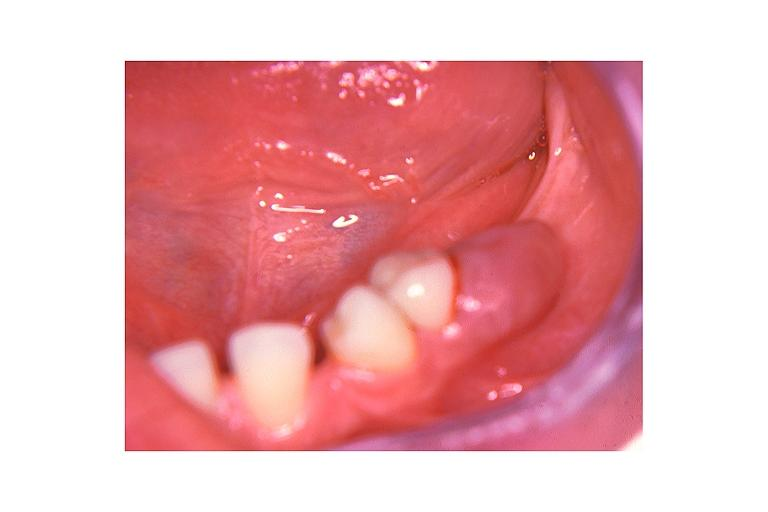s testicle present?
Answer the question using a single word or phrase. No 